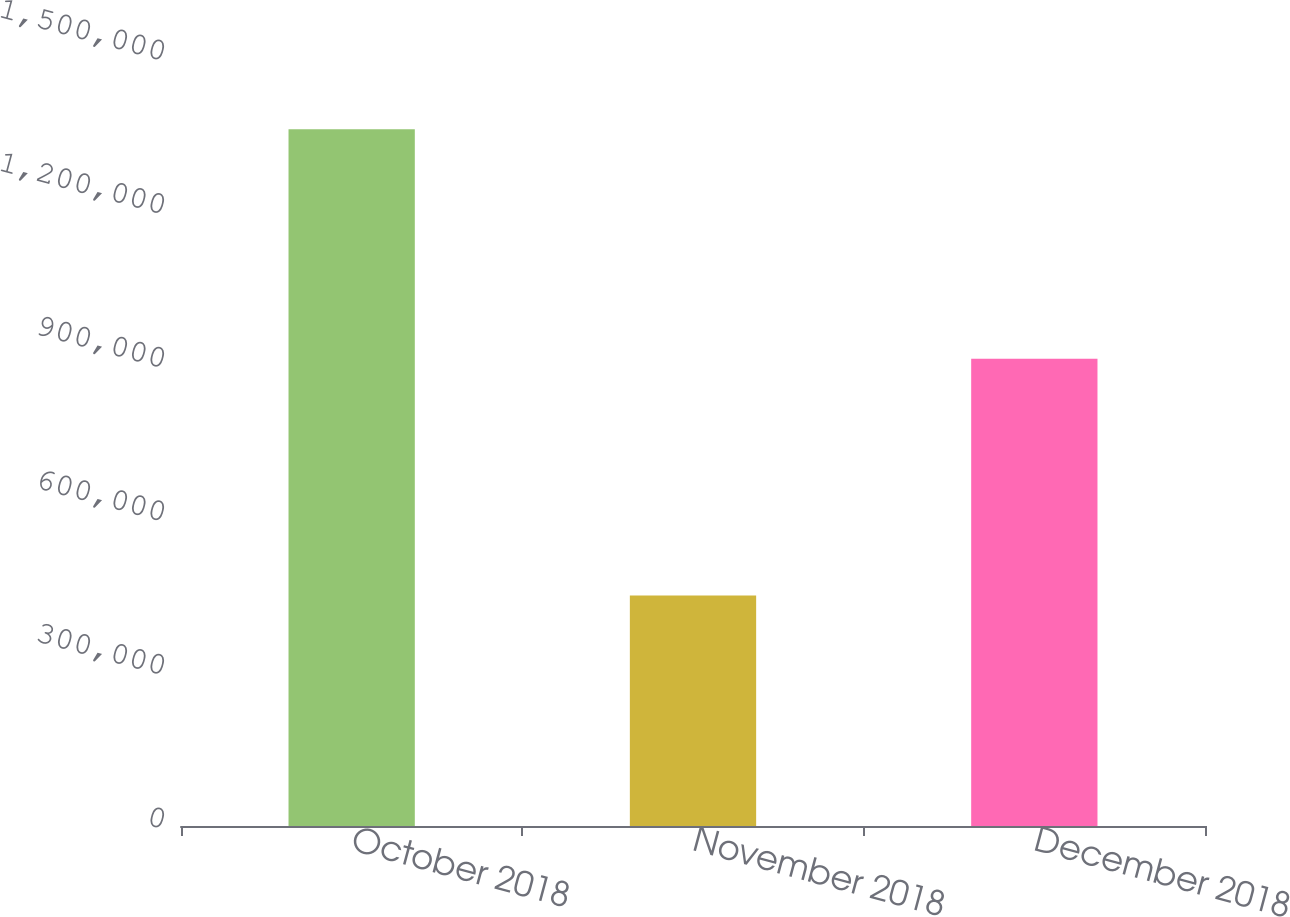Convert chart. <chart><loc_0><loc_0><loc_500><loc_500><bar_chart><fcel>October 2018<fcel>November 2018<fcel>December 2018<nl><fcel>1.36099e+06<fcel>450000<fcel>912360<nl></chart> 